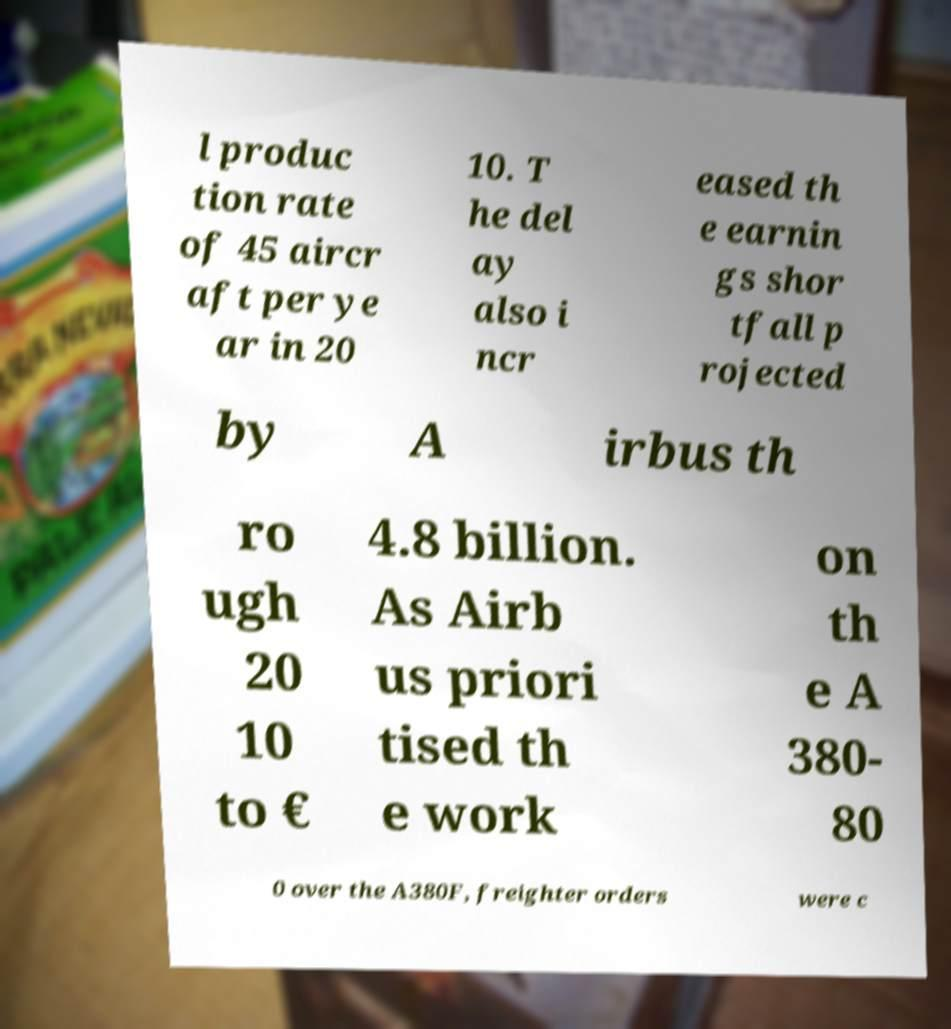What messages or text are displayed in this image? I need them in a readable, typed format. l produc tion rate of 45 aircr aft per ye ar in 20 10. T he del ay also i ncr eased th e earnin gs shor tfall p rojected by A irbus th ro ugh 20 10 to € 4.8 billion. As Airb us priori tised th e work on th e A 380- 80 0 over the A380F, freighter orders were c 